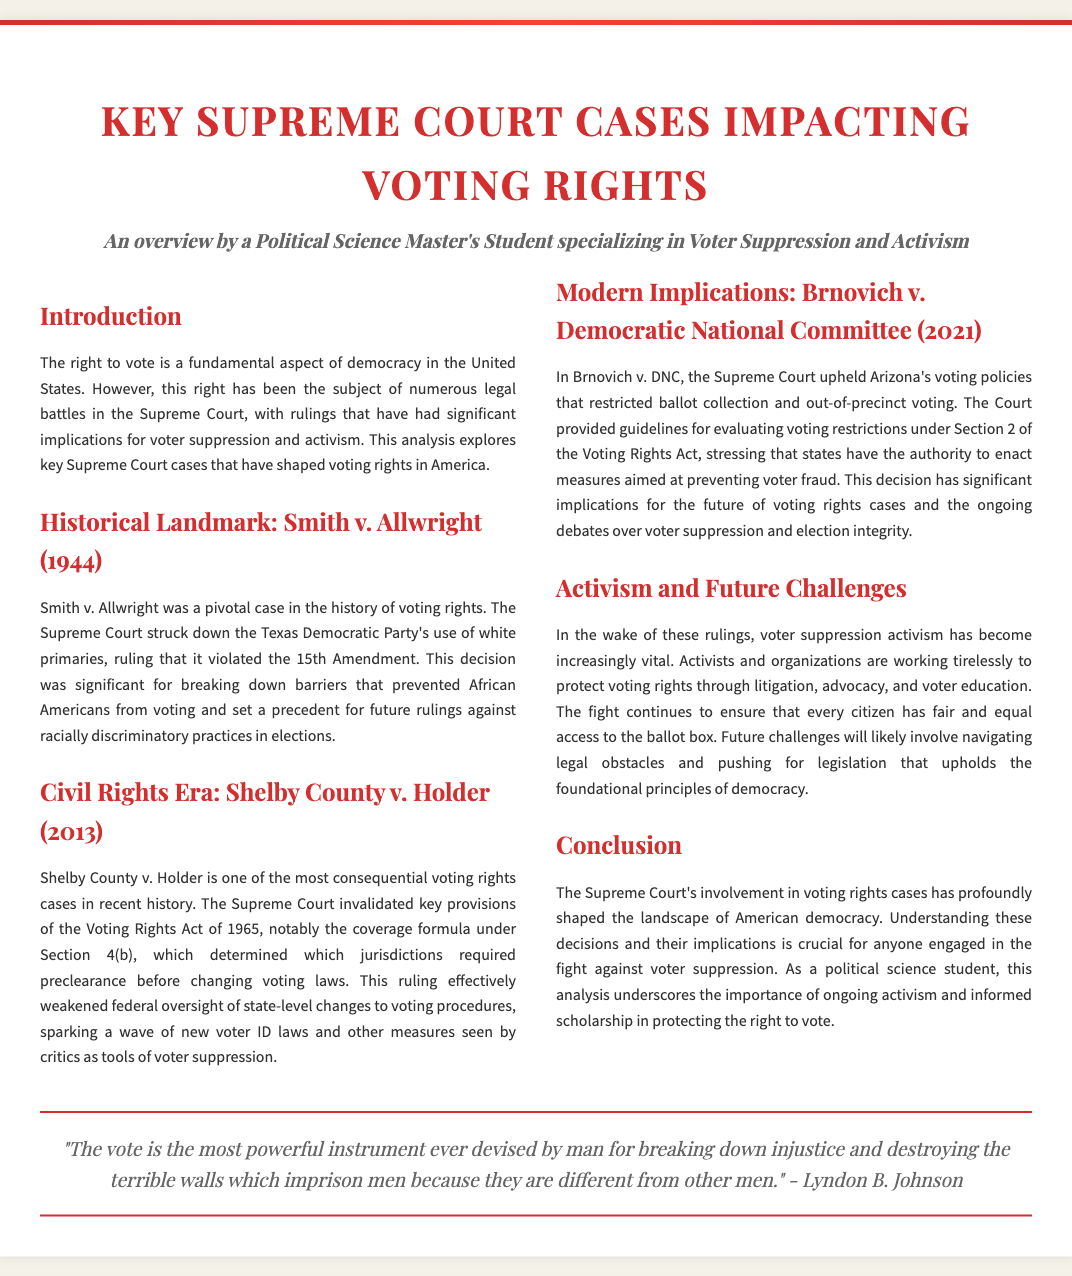What was the ruling in Smith v. Allwright? The Supreme Court struck down the Texas Democratic Party's use of white primaries, ruling that it violated the 15th Amendment.
Answer: It violated the 15th Amendment What year was Shelby County v. Holder decided? Shelby County v. Holder was decided in 2013, as stated prominently in the section heading.
Answer: 2013 What does the ruling in Brnovich v. DNC pertain to? The Supreme Court upheld Arizona's voting policies that restricted ballot collection and out-of-precinct voting, according to the analysis.
Answer: Voting policies What is the main emphasis of the conclusion? The conclusion highlights the importance of ongoing activism and informed scholarship in protecting the right to vote.
Answer: Ongoing activism Who is quoted in the document? The quote featured in the document is attributed to Lyndon B. Johnson.
Answer: Lyndon B. Johnson What is the overarching theme of this document? The document discusses key Supreme Court cases impacting voting rights, with a focus on voter suppression and activism.
Answer: Voting rights What is the function of the quote in the document? The quote serves to emphasize the significance of voting as a tool for justice and equality.
Answer: Emphasize voting significance What are the historical implications discussed regarding Smith v. Allwright? The case was significant for breaking down barriers that prevented African Americans from voting.
Answer: Breaking down barriers What does the section titled 'Activism and Future Challenges' focus on? It focuses on the efforts of activists and organizations to protect voting rights through various means.
Answer: Protecting voting rights 